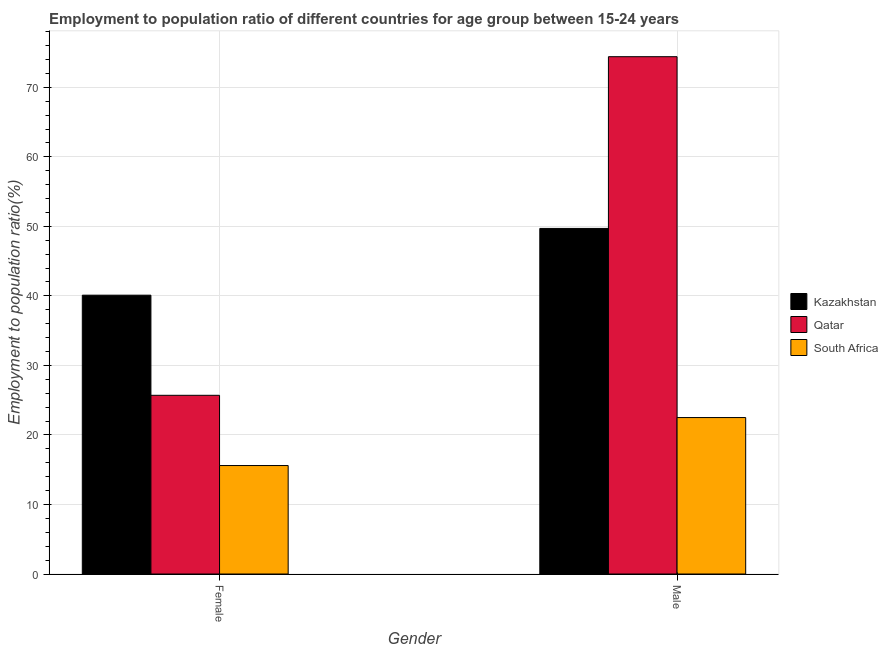How many different coloured bars are there?
Keep it short and to the point. 3. How many groups of bars are there?
Give a very brief answer. 2. Are the number of bars per tick equal to the number of legend labels?
Offer a terse response. Yes. Are the number of bars on each tick of the X-axis equal?
Provide a succinct answer. Yes. How many bars are there on the 2nd tick from the right?
Give a very brief answer. 3. What is the employment to population ratio(female) in Kazakhstan?
Give a very brief answer. 40.1. Across all countries, what is the maximum employment to population ratio(female)?
Offer a very short reply. 40.1. In which country was the employment to population ratio(male) maximum?
Offer a terse response. Qatar. In which country was the employment to population ratio(female) minimum?
Give a very brief answer. South Africa. What is the total employment to population ratio(female) in the graph?
Offer a very short reply. 81.4. What is the difference between the employment to population ratio(female) in South Africa and that in Kazakhstan?
Make the answer very short. -24.5. What is the difference between the employment to population ratio(male) in Qatar and the employment to population ratio(female) in Kazakhstan?
Your answer should be very brief. 34.3. What is the average employment to population ratio(male) per country?
Your answer should be very brief. 48.87. What is the difference between the employment to population ratio(female) and employment to population ratio(male) in Qatar?
Your answer should be compact. -48.7. What is the ratio of the employment to population ratio(male) in South Africa to that in Kazakhstan?
Make the answer very short. 0.45. What does the 3rd bar from the left in Female represents?
Give a very brief answer. South Africa. What does the 2nd bar from the right in Female represents?
Your response must be concise. Qatar. How many bars are there?
Make the answer very short. 6. How many countries are there in the graph?
Ensure brevity in your answer.  3. How many legend labels are there?
Provide a short and direct response. 3. What is the title of the graph?
Provide a short and direct response. Employment to population ratio of different countries for age group between 15-24 years. Does "Iraq" appear as one of the legend labels in the graph?
Make the answer very short. No. What is the label or title of the X-axis?
Make the answer very short. Gender. What is the label or title of the Y-axis?
Keep it short and to the point. Employment to population ratio(%). What is the Employment to population ratio(%) in Kazakhstan in Female?
Provide a short and direct response. 40.1. What is the Employment to population ratio(%) in Qatar in Female?
Provide a short and direct response. 25.7. What is the Employment to population ratio(%) of South Africa in Female?
Offer a very short reply. 15.6. What is the Employment to population ratio(%) of Kazakhstan in Male?
Ensure brevity in your answer.  49.7. What is the Employment to population ratio(%) in Qatar in Male?
Offer a very short reply. 74.4. Across all Gender, what is the maximum Employment to population ratio(%) of Kazakhstan?
Keep it short and to the point. 49.7. Across all Gender, what is the maximum Employment to population ratio(%) in Qatar?
Your response must be concise. 74.4. Across all Gender, what is the maximum Employment to population ratio(%) in South Africa?
Provide a short and direct response. 22.5. Across all Gender, what is the minimum Employment to population ratio(%) of Kazakhstan?
Ensure brevity in your answer.  40.1. Across all Gender, what is the minimum Employment to population ratio(%) in Qatar?
Make the answer very short. 25.7. Across all Gender, what is the minimum Employment to population ratio(%) of South Africa?
Offer a very short reply. 15.6. What is the total Employment to population ratio(%) in Kazakhstan in the graph?
Offer a terse response. 89.8. What is the total Employment to population ratio(%) in Qatar in the graph?
Ensure brevity in your answer.  100.1. What is the total Employment to population ratio(%) in South Africa in the graph?
Provide a short and direct response. 38.1. What is the difference between the Employment to population ratio(%) of Qatar in Female and that in Male?
Make the answer very short. -48.7. What is the difference between the Employment to population ratio(%) in Kazakhstan in Female and the Employment to population ratio(%) in Qatar in Male?
Keep it short and to the point. -34.3. What is the difference between the Employment to population ratio(%) in Kazakhstan in Female and the Employment to population ratio(%) in South Africa in Male?
Offer a terse response. 17.6. What is the difference between the Employment to population ratio(%) in Qatar in Female and the Employment to population ratio(%) in South Africa in Male?
Offer a terse response. 3.2. What is the average Employment to population ratio(%) of Kazakhstan per Gender?
Offer a very short reply. 44.9. What is the average Employment to population ratio(%) of Qatar per Gender?
Provide a succinct answer. 50.05. What is the average Employment to population ratio(%) in South Africa per Gender?
Offer a terse response. 19.05. What is the difference between the Employment to population ratio(%) of Kazakhstan and Employment to population ratio(%) of South Africa in Female?
Your answer should be compact. 24.5. What is the difference between the Employment to population ratio(%) of Qatar and Employment to population ratio(%) of South Africa in Female?
Keep it short and to the point. 10.1. What is the difference between the Employment to population ratio(%) of Kazakhstan and Employment to population ratio(%) of Qatar in Male?
Ensure brevity in your answer.  -24.7. What is the difference between the Employment to population ratio(%) in Kazakhstan and Employment to population ratio(%) in South Africa in Male?
Make the answer very short. 27.2. What is the difference between the Employment to population ratio(%) of Qatar and Employment to population ratio(%) of South Africa in Male?
Your answer should be compact. 51.9. What is the ratio of the Employment to population ratio(%) of Kazakhstan in Female to that in Male?
Offer a very short reply. 0.81. What is the ratio of the Employment to population ratio(%) in Qatar in Female to that in Male?
Your response must be concise. 0.35. What is the ratio of the Employment to population ratio(%) in South Africa in Female to that in Male?
Ensure brevity in your answer.  0.69. What is the difference between the highest and the second highest Employment to population ratio(%) in Qatar?
Offer a terse response. 48.7. What is the difference between the highest and the second highest Employment to population ratio(%) of South Africa?
Offer a very short reply. 6.9. What is the difference between the highest and the lowest Employment to population ratio(%) of Kazakhstan?
Make the answer very short. 9.6. What is the difference between the highest and the lowest Employment to population ratio(%) in Qatar?
Your answer should be very brief. 48.7. What is the difference between the highest and the lowest Employment to population ratio(%) of South Africa?
Offer a terse response. 6.9. 